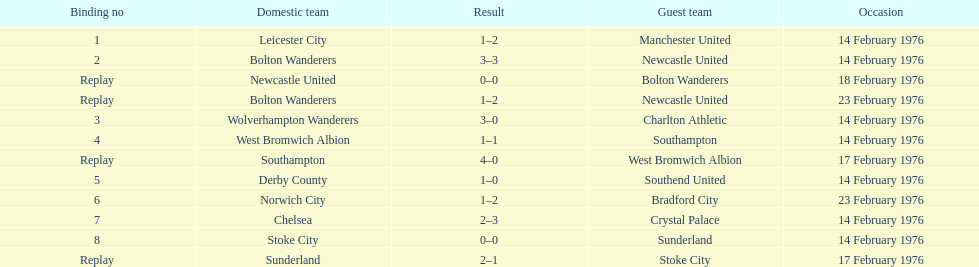Who had a better score, manchester united or wolverhampton wanderers? Wolverhampton Wanderers. 